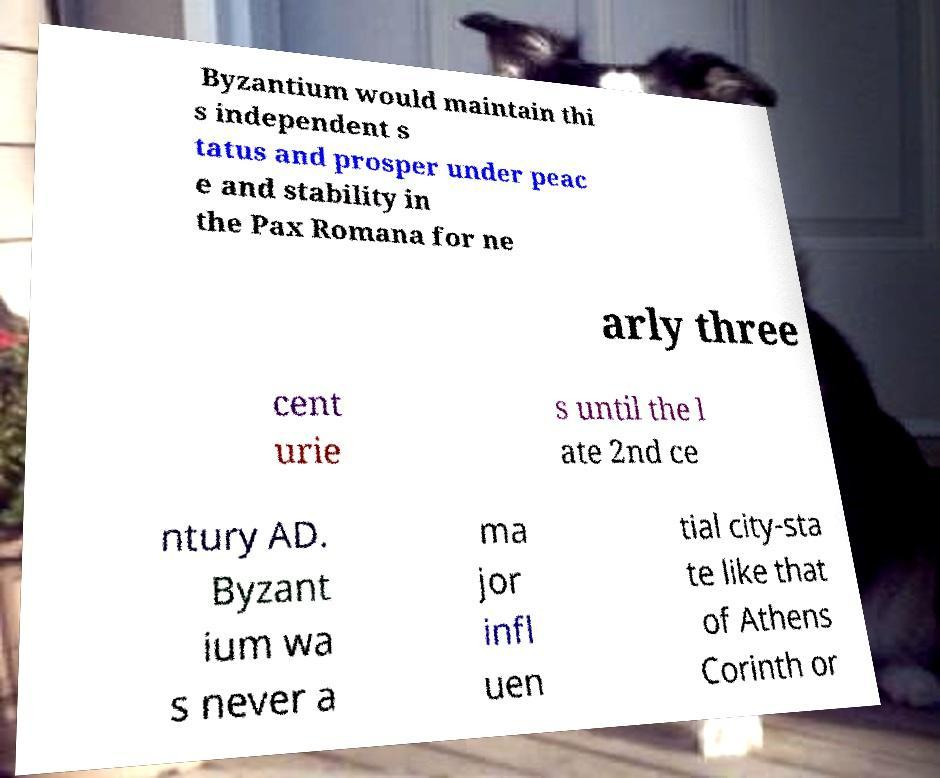For documentation purposes, I need the text within this image transcribed. Could you provide that? Byzantium would maintain thi s independent s tatus and prosper under peac e and stability in the Pax Romana for ne arly three cent urie s until the l ate 2nd ce ntury AD. Byzant ium wa s never a ma jor infl uen tial city-sta te like that of Athens Corinth or 